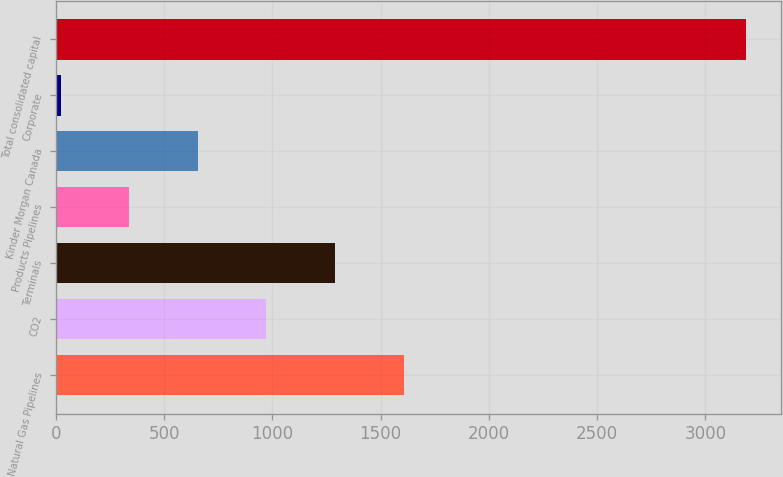<chart> <loc_0><loc_0><loc_500><loc_500><bar_chart><fcel>Natural Gas Pipelines<fcel>CO2<fcel>Terminals<fcel>Products Pipelines<fcel>Kinder Morgan Canada<fcel>Corporate<fcel>Total consolidated capital<nl><fcel>1605.5<fcel>972.5<fcel>1289<fcel>339.5<fcel>656<fcel>23<fcel>3188<nl></chart> 